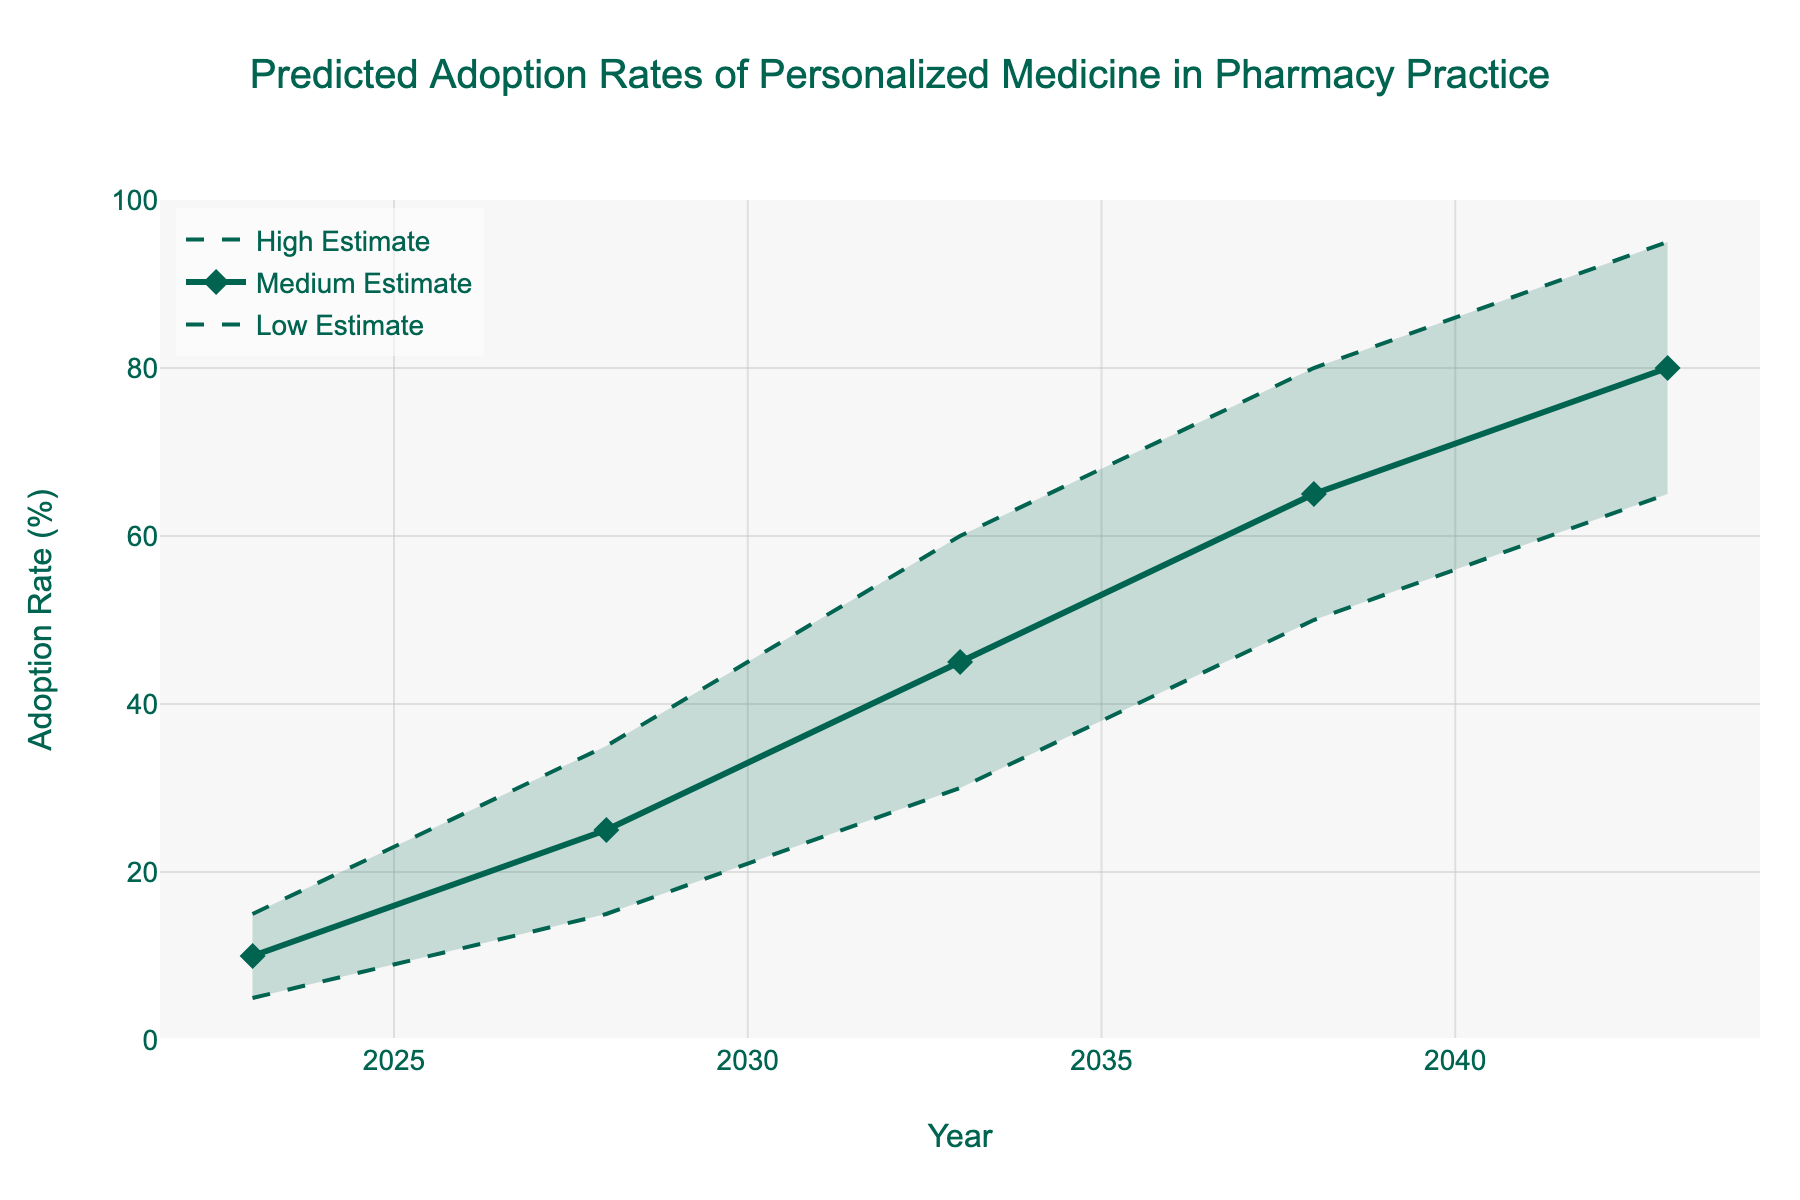what is the title of the figure? The title of the figure is usually found at the top of the chart, often emphasized with larger or bold fonts for clarity.
Answer: Predicted Adoption Rates of Personalized Medicine in Pharmacy Practice what are the three different categories of adoption rates shown in the figure? By examining the legend or labels within the chart, we can identify the named categories.
Answer: Low Estimate, Medium Estimate, High Estimate in which year is the adoption rate at its highest based on the "High Estimate"? We look for the peak value along the "High Estimate" line.
Answer: 2043 what is the range of the adoption rate in 2038? The adoption range can be derived from the lowest and highest values in 2038.
Answer: 50% to 80% what is the difference between the high estimate and the low estimate adoption rate in 2043? Subtract the value of the Low Estimate from that of the High Estimate for 2043.
Answer: 95% - 65% = 30% which estimate shows the most rapid growth from 2023 to 2028 and by how much? We compute the difference for each estimate and compare them.
Answer: High Estimate, 20% how does the "Medium Estimate" adoption rate in 2028 compare with the "Low Estimate" in 2033? Compare the particular values by checking and contrasting the data points.
Answer: 25% in 2028 vs. 30% in 2033, so Medium Estimate in 2028 is less how consistent is the growth pattern for "Low Estimate" over the years shown? By examining the Low Estimate trajectory, one can determine its consistency and smoothness.
Answer: The growth shows a steady, linear increase what insight can be drawn from the shaded area in the fan chart? The shaded area indicates the uncertainty/confidence interval between the low and high estimates. It visualizes the potential variability in predictions.
Answer: The shaded area represents the possible range of adoption rates between the low and high estimates, showing increasing uncertainty over time why might the fan chart be a suitable choice for this data? The fan chart is well-suited for showing a range of future possibilities and uncertainties.
Answer: Because it captures the range of predicted adoption rates, highlighting the uncertainty in future trends 